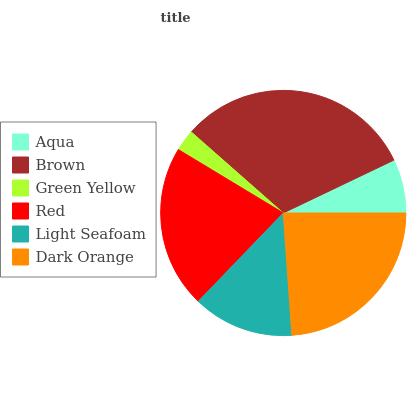Is Green Yellow the minimum?
Answer yes or no. Yes. Is Brown the maximum?
Answer yes or no. Yes. Is Brown the minimum?
Answer yes or no. No. Is Green Yellow the maximum?
Answer yes or no. No. Is Brown greater than Green Yellow?
Answer yes or no. Yes. Is Green Yellow less than Brown?
Answer yes or no. Yes. Is Green Yellow greater than Brown?
Answer yes or no. No. Is Brown less than Green Yellow?
Answer yes or no. No. Is Red the high median?
Answer yes or no. Yes. Is Light Seafoam the low median?
Answer yes or no. Yes. Is Green Yellow the high median?
Answer yes or no. No. Is Dark Orange the low median?
Answer yes or no. No. 